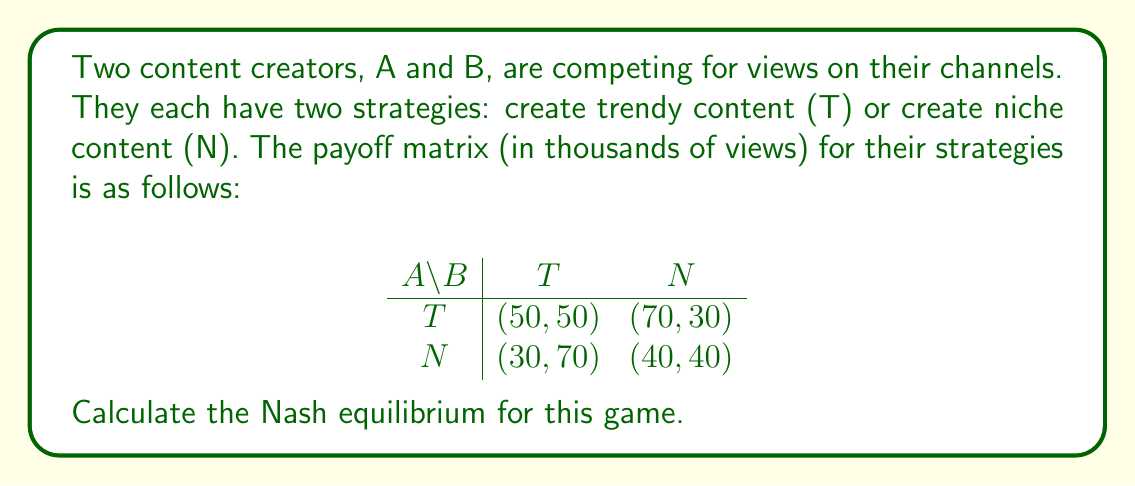Can you solve this math problem? To find the Nash equilibrium, we need to determine if there are any pure strategy equilibria or if we need to calculate a mixed strategy equilibrium.

Step 1: Check for pure strategy Nash equilibria
We examine each outcome to see if any player can unilaterally improve their payoff by changing their strategy.

1. (T, T): Neither player can improve by switching to N.
2. (T, N): B can improve by switching to T (70 > 30).
3. (N, T): A can improve by switching to T (50 > 30).
4. (N, N): Both players can improve by switching to T.

We find that (T, T) is a pure strategy Nash equilibrium.

Step 2: Verify if (T, T) is the only equilibrium
Since we found a pure strategy equilibrium, we don't need to calculate mixed strategies. However, let's verify that this is the only equilibrium.

For creator A:
- If B plays T, A's best response is T (50 > 30)
- If B plays N, A's best response is T (70 > 40)

For creator B:
- If A plays T, B's best response is T (50 > 30)
- If A plays N, B's best response is T (70 > 40)

This confirms that (T, T) is the only Nash equilibrium in this game.
Answer: The Nash equilibrium for this game is (T, T), where both content creators choose to create trendy content, resulting in a payoff of 50,000 views for each creator. 